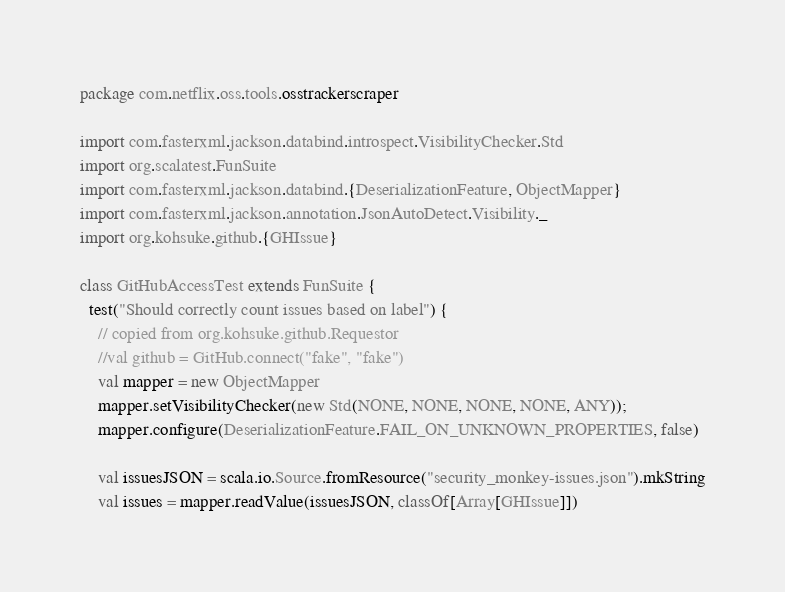<code> <loc_0><loc_0><loc_500><loc_500><_Scala_>package com.netflix.oss.tools.osstrackerscraper

import com.fasterxml.jackson.databind.introspect.VisibilityChecker.Std
import org.scalatest.FunSuite
import com.fasterxml.jackson.databind.{DeserializationFeature, ObjectMapper}
import com.fasterxml.jackson.annotation.JsonAutoDetect.Visibility._
import org.kohsuke.github.{GHIssue}

class GitHubAccessTest extends FunSuite {
  test("Should correctly count issues based on label") {
    // copied from org.kohsuke.github.Requestor
    //val github = GitHub.connect("fake", "fake")
    val mapper = new ObjectMapper
    mapper.setVisibilityChecker(new Std(NONE, NONE, NONE, NONE, ANY));
    mapper.configure(DeserializationFeature.FAIL_ON_UNKNOWN_PROPERTIES, false)

    val issuesJSON = scala.io.Source.fromResource("security_monkey-issues.json").mkString
    val issues = mapper.readValue(issuesJSON, classOf[Array[GHIssue]])
</code> 